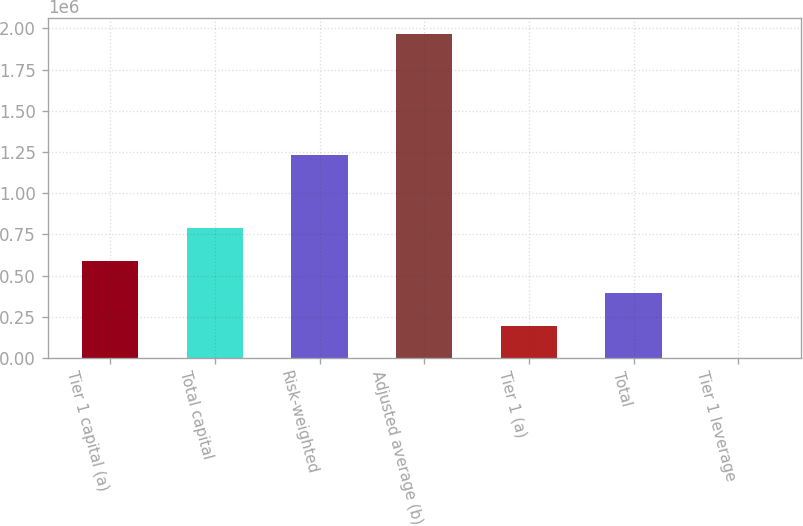Convert chart to OTSL. <chart><loc_0><loc_0><loc_500><loc_500><bar_chart><fcel>Tier 1 capital (a)<fcel>Total capital<fcel>Risk-weighted<fcel>Adjusted average (b)<fcel>Tier 1 (a)<fcel>Total<fcel>Tier 1 leverage<nl><fcel>590445<fcel>787257<fcel>1.23036e+06<fcel>1.96813e+06<fcel>196820<fcel>393633<fcel>8<nl></chart> 